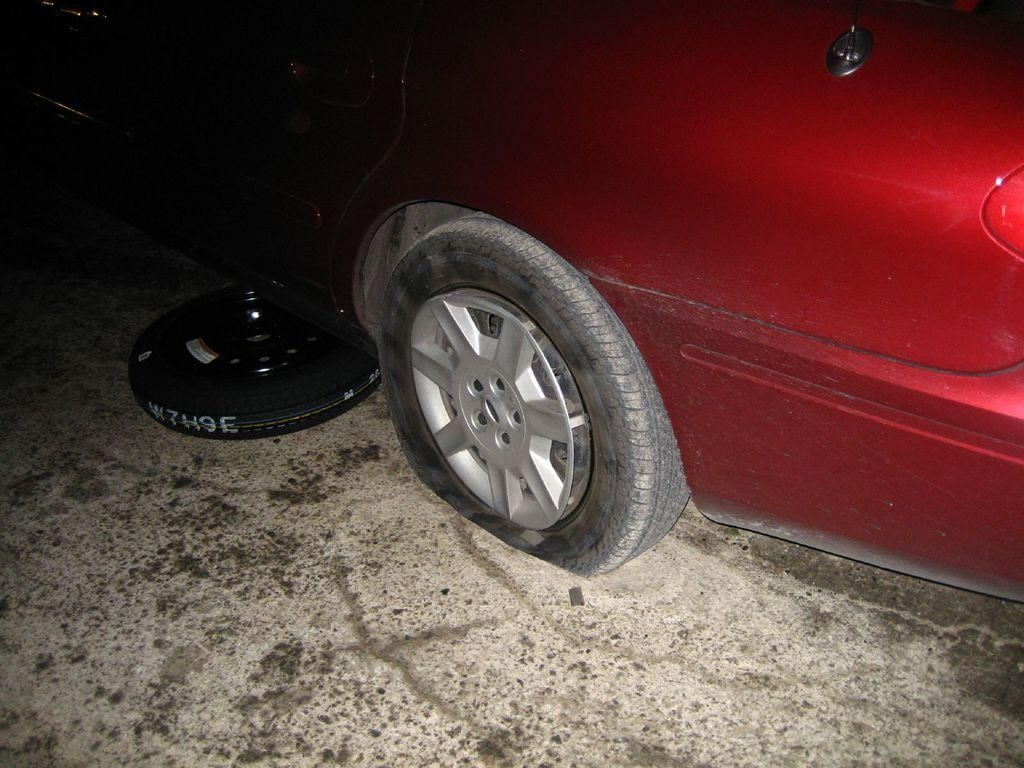What color is the vehicle in the image? The vehicle in the image is red-colored. Can you describe any specific features of the vehicle? There is a black-colored tire on the left side of the vehicle in the image. How does the vehicle take flight in the image? The vehicle does not take flight in the image; it is a ground vehicle with wheels. 